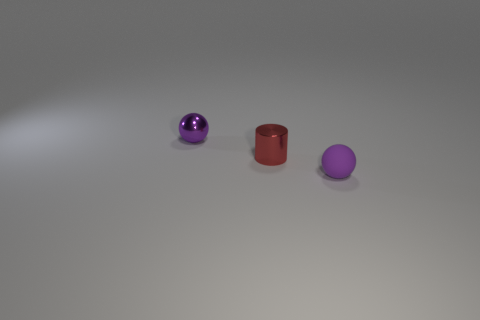Add 3 tiny matte objects. How many objects exist? 6 Subtract all balls. How many objects are left? 1 Add 3 red shiny cylinders. How many red shiny cylinders are left? 4 Add 3 tiny brown metal cylinders. How many tiny brown metal cylinders exist? 3 Subtract 0 gray blocks. How many objects are left? 3 Subtract all gray cylinders. Subtract all cyan balls. How many cylinders are left? 1 Subtract all cyan blocks. How many brown balls are left? 0 Subtract all large blue shiny cylinders. Subtract all purple rubber balls. How many objects are left? 2 